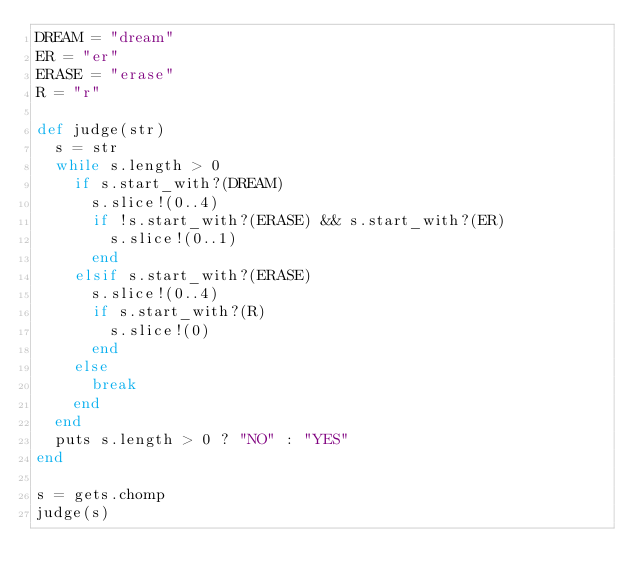Convert code to text. <code><loc_0><loc_0><loc_500><loc_500><_Ruby_>DREAM = "dream"
ER = "er"
ERASE = "erase"
R = "r"

def judge(str)
  s = str
  while s.length > 0
    if s.start_with?(DREAM)
      s.slice!(0..4)
      if !s.start_with?(ERASE) && s.start_with?(ER)
        s.slice!(0..1)
      end
    elsif s.start_with?(ERASE)
      s.slice!(0..4)
      if s.start_with?(R)
        s.slice!(0)
      end
    else
      break
    end
  end
  puts s.length > 0 ? "NO" : "YES"
end

s = gets.chomp
judge(s)
</code> 